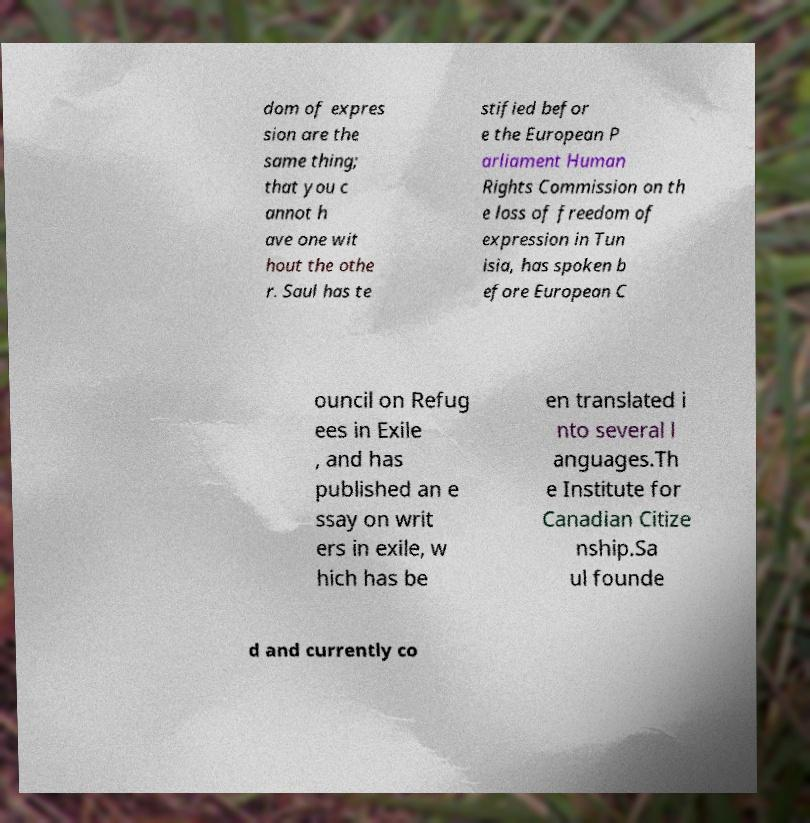Could you extract and type out the text from this image? dom of expres sion are the same thing; that you c annot h ave one wit hout the othe r. Saul has te stified befor e the European P arliament Human Rights Commission on th e loss of freedom of expression in Tun isia, has spoken b efore European C ouncil on Refug ees in Exile , and has published an e ssay on writ ers in exile, w hich has be en translated i nto several l anguages.Th e Institute for Canadian Citize nship.Sa ul founde d and currently co 